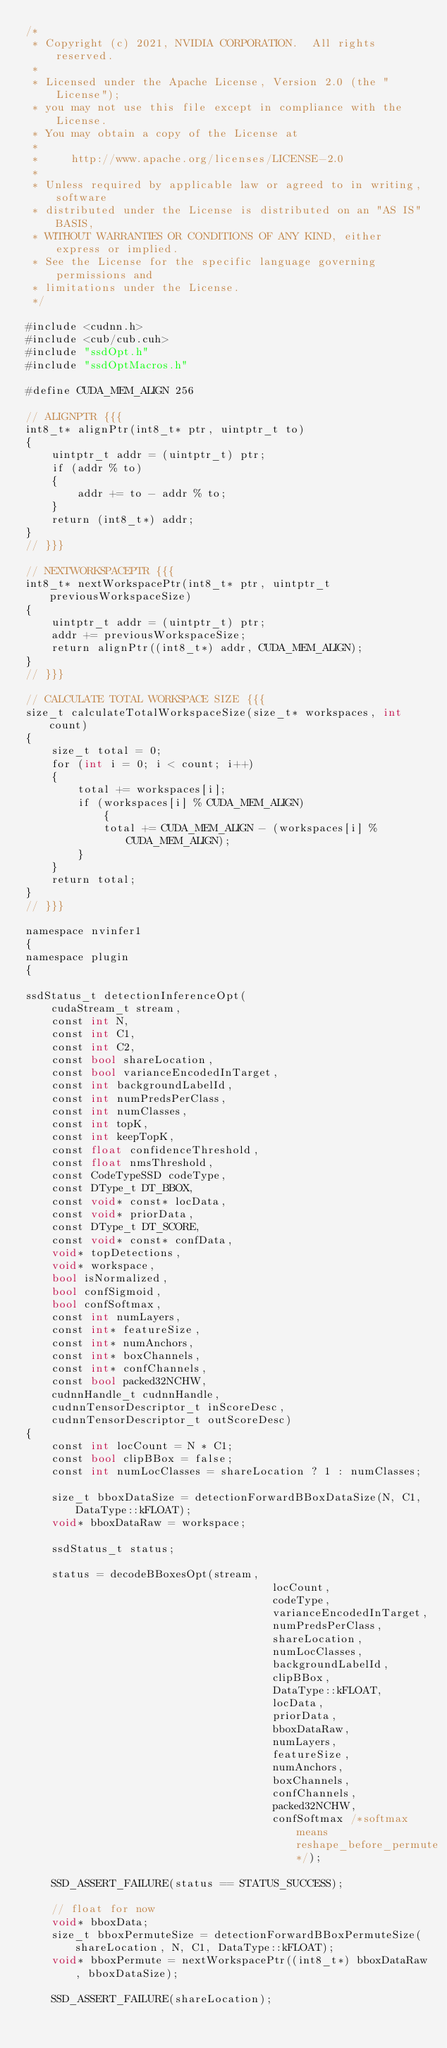<code> <loc_0><loc_0><loc_500><loc_500><_Cuda_>/*
 * Copyright (c) 2021, NVIDIA CORPORATION.  All rights reserved.
 *
 * Licensed under the Apache License, Version 2.0 (the "License");
 * you may not use this file except in compliance with the License.
 * You may obtain a copy of the License at
 *
 *     http://www.apache.org/licenses/LICENSE-2.0
 *
 * Unless required by applicable law or agreed to in writing, software
 * distributed under the License is distributed on an "AS IS" BASIS,
 * WITHOUT WARRANTIES OR CONDITIONS OF ANY KIND, either express or implied.
 * See the License for the specific language governing permissions and
 * limitations under the License.
 */

#include <cudnn.h>
#include <cub/cub.cuh>
#include "ssdOpt.h"
#include "ssdOptMacros.h"

#define CUDA_MEM_ALIGN 256

// ALIGNPTR {{{
int8_t* alignPtr(int8_t* ptr, uintptr_t to)
{
    uintptr_t addr = (uintptr_t) ptr;
    if (addr % to)
    {
        addr += to - addr % to;
    }
    return (int8_t*) addr;
}
// }}}

// NEXTWORKSPACEPTR {{{
int8_t* nextWorkspacePtr(int8_t* ptr, uintptr_t previousWorkspaceSize)
{
    uintptr_t addr = (uintptr_t) ptr;
    addr += previousWorkspaceSize;
    return alignPtr((int8_t*) addr, CUDA_MEM_ALIGN);
}
// }}}

// CALCULATE TOTAL WORKSPACE SIZE {{{
size_t calculateTotalWorkspaceSize(size_t* workspaces, int count)
{
    size_t total = 0;
    for (int i = 0; i < count; i++)
    {
        total += workspaces[i];
        if (workspaces[i] % CUDA_MEM_ALIGN)
            {
            total += CUDA_MEM_ALIGN - (workspaces[i] % CUDA_MEM_ALIGN);
        }
    }
    return total;
}
// }}}

namespace nvinfer1
{
namespace plugin
{

ssdStatus_t detectionInferenceOpt(
    cudaStream_t stream,
    const int N,
    const int C1,
    const int C2,
    const bool shareLocation,
    const bool varianceEncodedInTarget,
    const int backgroundLabelId,
    const int numPredsPerClass,
    const int numClasses,
    const int topK,
    const int keepTopK,
    const float confidenceThreshold,
    const float nmsThreshold,
    const CodeTypeSSD codeType,
    const DType_t DT_BBOX,
    const void* const* locData,
    const void* priorData,
    const DType_t DT_SCORE,
    const void* const* confData,
    void* topDetections,
    void* workspace,
    bool isNormalized,
    bool confSigmoid,
    bool confSoftmax,
    const int numLayers,
    const int* featureSize,
    const int* numAnchors,
    const int* boxChannels,
    const int* confChannels,
    const bool packed32NCHW,
    cudnnHandle_t cudnnHandle,
    cudnnTensorDescriptor_t inScoreDesc,
    cudnnTensorDescriptor_t outScoreDesc)
{
    const int locCount = N * C1;
    const bool clipBBox = false;
    const int numLocClasses = shareLocation ? 1 : numClasses;

    size_t bboxDataSize = detectionForwardBBoxDataSize(N, C1, DataType::kFLOAT);
    void* bboxDataRaw = workspace;

    ssdStatus_t status;

    status = decodeBBoxesOpt(stream,
                                      locCount,
                                      codeType,
                                      varianceEncodedInTarget,
                                      numPredsPerClass,
                                      shareLocation,
                                      numLocClasses,
                                      backgroundLabelId,
                                      clipBBox,
                                      DataType::kFLOAT,
                                      locData,
                                      priorData,
                                      bboxDataRaw,
                                      numLayers,
                                      featureSize,
                                      numAnchors,
                                      boxChannels,
                                      confChannels,
                                      packed32NCHW,
                                      confSoftmax /*softmax means reshape_before_permute*/);

    SSD_ASSERT_FAILURE(status == STATUS_SUCCESS);

    // float for now
    void* bboxData;
    size_t bboxPermuteSize = detectionForwardBBoxPermuteSize(shareLocation, N, C1, DataType::kFLOAT);
    void* bboxPermute = nextWorkspacePtr((int8_t*) bboxDataRaw, bboxDataSize);

    SSD_ASSERT_FAILURE(shareLocation);</code> 